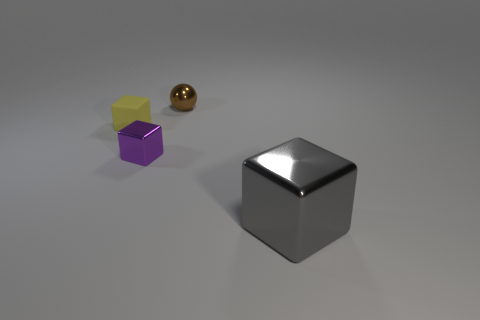Subtract 1 cubes. How many cubes are left? 2 Add 1 tiny green cylinders. How many objects exist? 5 Subtract all blocks. How many objects are left? 1 Add 3 purple blocks. How many purple blocks exist? 4 Subtract 0 purple spheres. How many objects are left? 4 Subtract all rubber blocks. Subtract all tiny gray metallic objects. How many objects are left? 3 Add 2 tiny brown balls. How many tiny brown balls are left? 3 